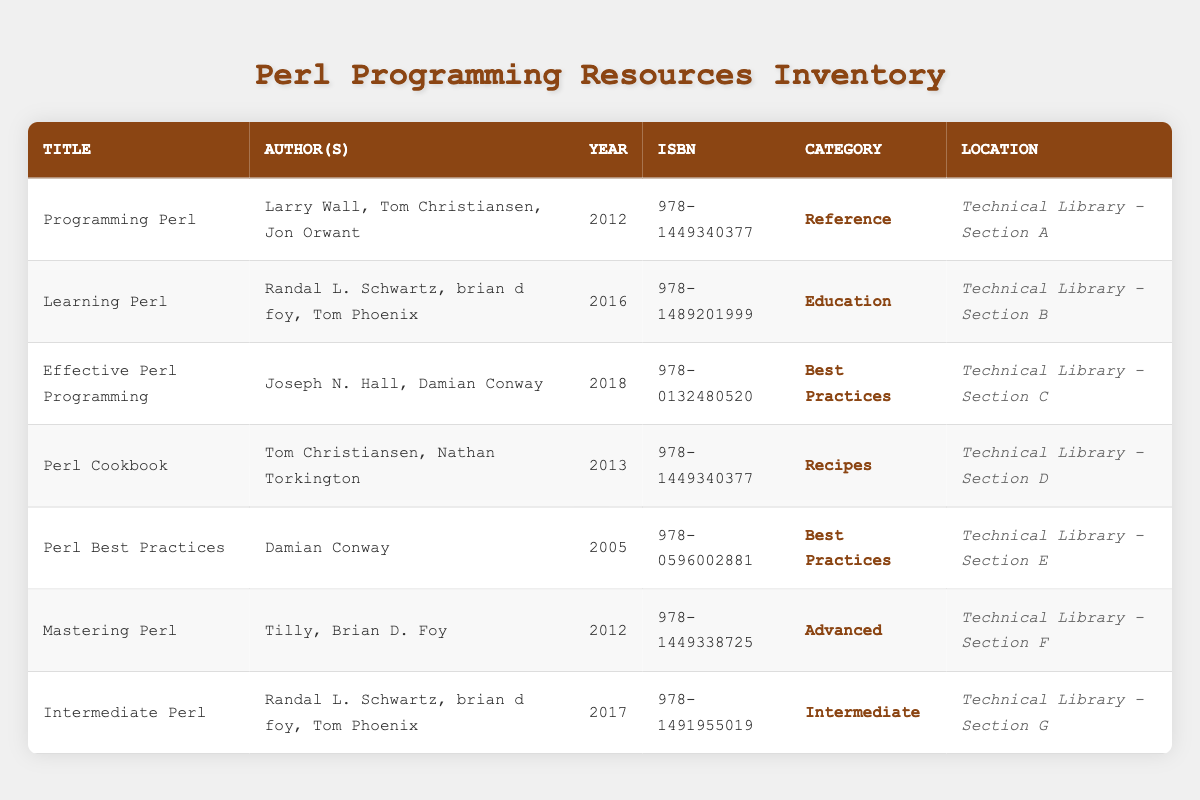What is the title of the book authored by Larry Wall? The table shows that the book authored by Larry Wall is titled "Programming Perl." This can be found directly by scanning the Author(s) column.
Answer: Programming Perl Which book was published in 2005? The table indicates that "Perl Best Practices" was published in 2005, as seen in the Year column for that title.
Answer: Perl Best Practices How many books are categorized as "Best Practices"? By examining the table, two books have the category "Best Practices": "Effective Perl Programming" and "Perl Best Practices." Therefore, the count is 2.
Answer: 2 Which book has the ISBN number 978-1489201999? The table reveals that the book corresponding to the ISBN number 978-1489201999 is "Learning Perl." This information is readily available by checking the ISBN column.
Answer: Learning Perl Is there a book that was published in 2018? Yes, the table confirms that "Effective Perl Programming" was published in 2018, as indicated in the Year column.
Answer: Yes What is the average publication year of the books listed in the table? To find the average publication year, we first total the publication years: 2012 + 2016 + 2018 + 2013 + 2005 + 2012 + 2017 = 1693. There are 7 books, so the average year is 1693 divided by 7, which equals approximately 241.857. Rounding gives us a publication year of 2012.
Answer: 2012 Which category has the most books listed, and how many books are in that category? By analyzing the table, the categories show that "Best Practices" has 2 books ("Effective Perl Programming" and "Perl Best Practices"), while the other categories have either 1 or 0 books. Thus, "Best Practices" is the most populated category.
Answer: Best Practices, 2 Is "Intermediate Perl" located in Section C of the Technical Library? No, "Intermediate Perl" is located in Section G, not Section C. This can be verified by checking the Location column for that specific title.
Answer: No Which authors contributed to the book "Programming Perl"? The authors for "Programming Perl" are Larry Wall, Tom Christiansen, and Jon Orwant. This is provided directly in the Author(s) column corresponding to that title.
Answer: Larry Wall, Tom Christiansen, Jon Orwant 